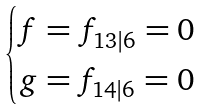<formula> <loc_0><loc_0><loc_500><loc_500>\begin{cases} f = f _ { 1 3 | 6 } = 0 \\ g = f _ { 1 4 | 6 } = 0 \end{cases}</formula> 